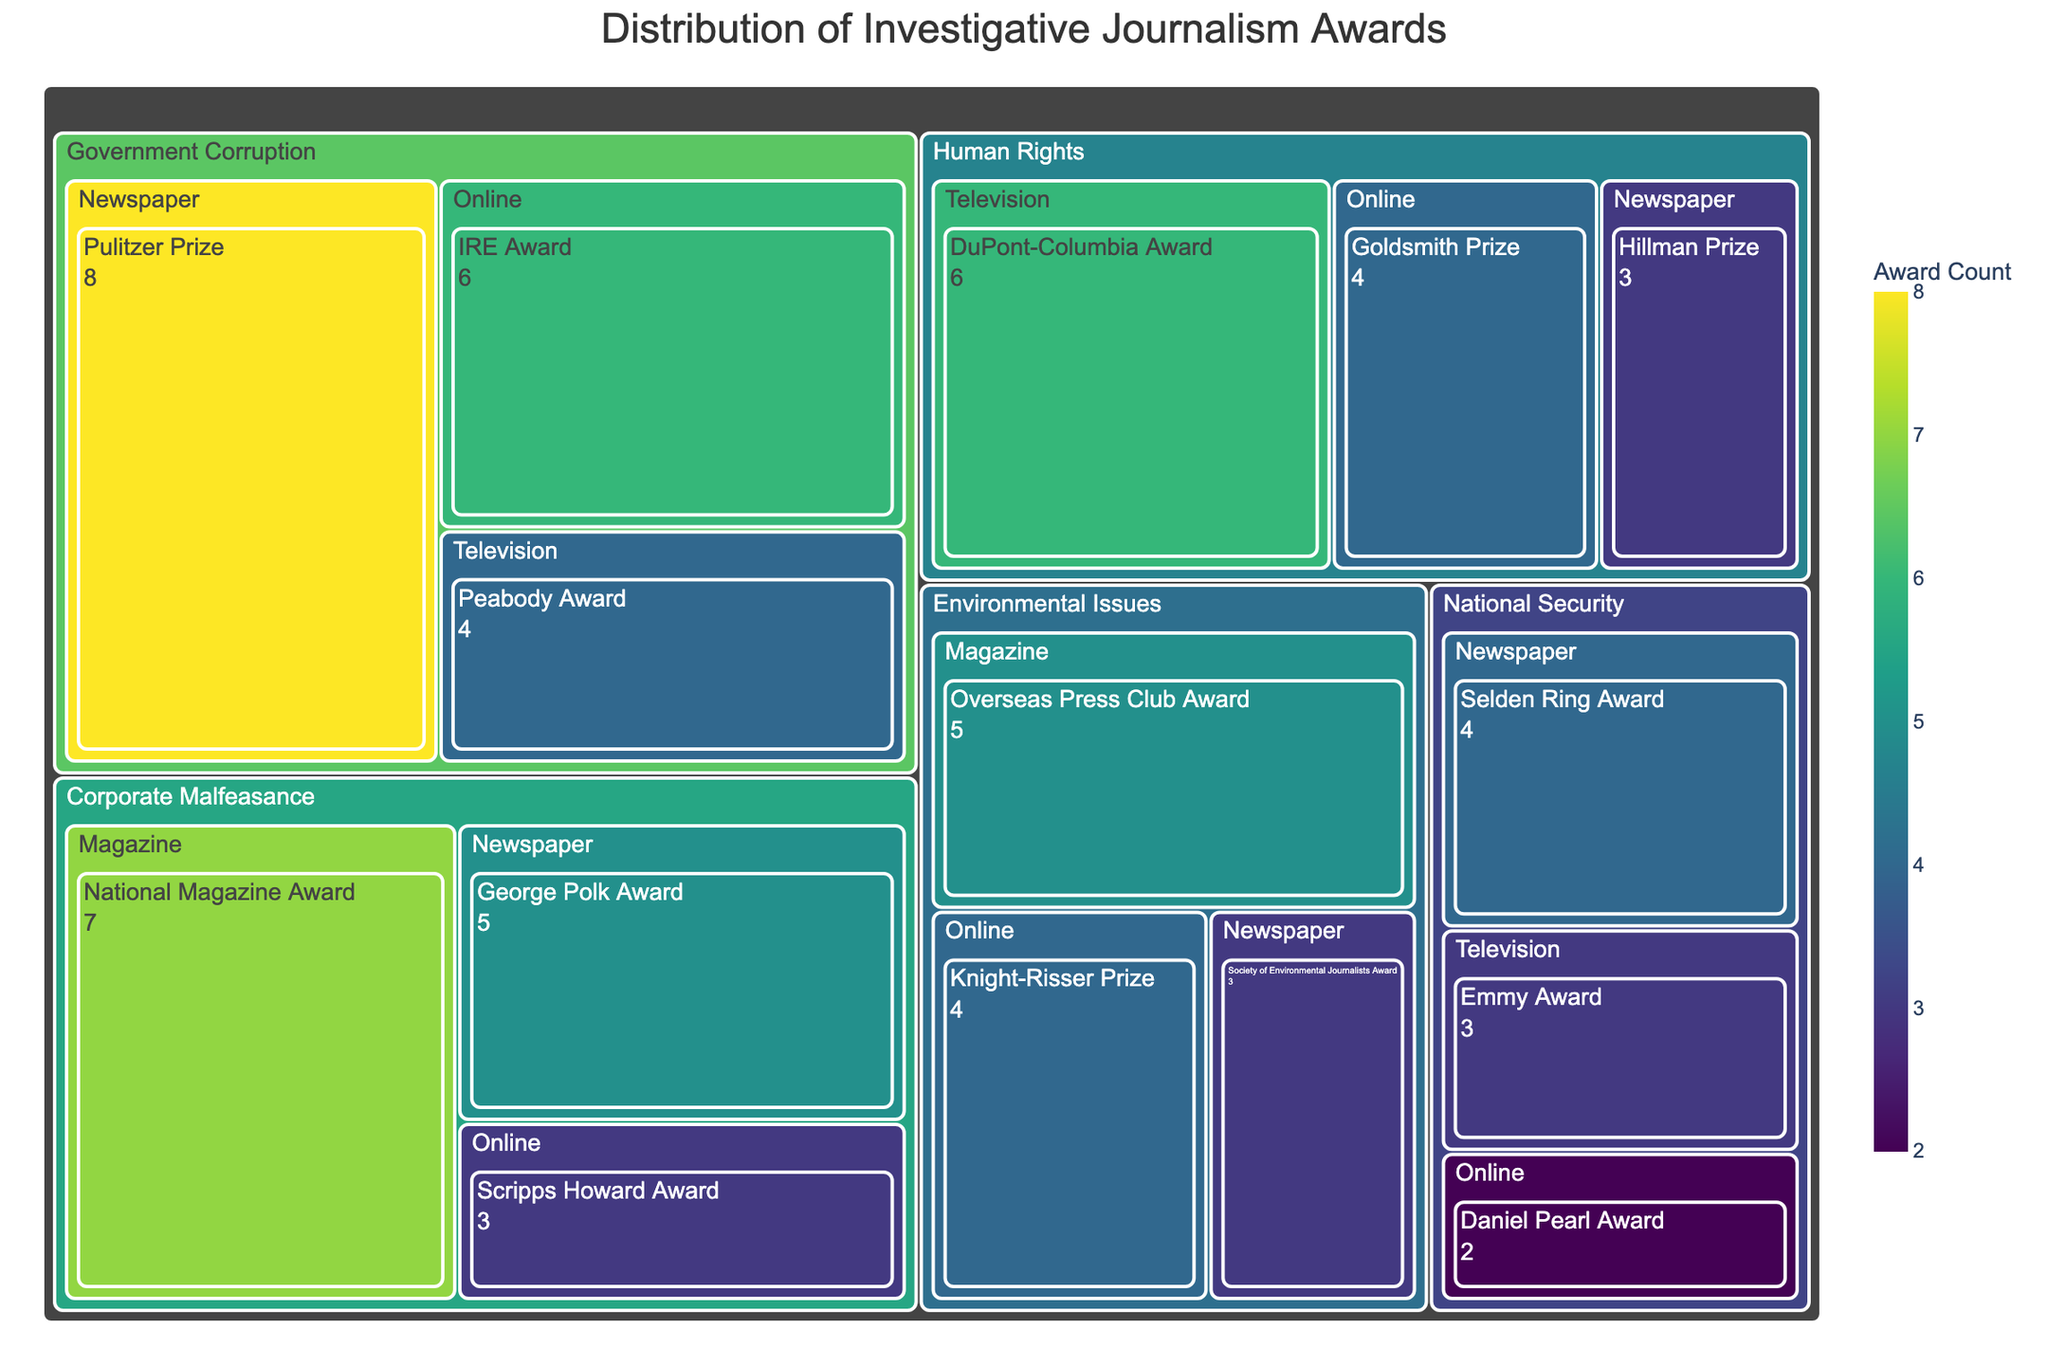How many awards are listed for Government Corruption? Look at the Government Corruption section and sum the values for each publication type: 8 (Newspaper) + 6 (Online) + 4 (Television) = 18
Answer: 18 Which category has the highest total number of awards? Compare the total count of awards across all categories by summing each category's values: Government Corruption = 18, Corporate Malfeasance = 15, Human Rights = 13, Environmental Issues = 12, National Security = 9. Government Corruption has the highest total with 18 awards.
Answer: Government Corruption What is the total number of awards for Online publications across all categories? Add the counts for Online publications: Government Corruption = 6, Corporate Malfeasance = 3, Human Rights = 4, Environmental Issues = 4, National Security = 2. Total = 6 + 3 + 4 + 4 + 2 = 19
Answer: 19 Which award has the highest count for Environmental Issues? Look within the Environmental Issues section and compare the values for the different awards: Overseas Press Club Award (5), Knight-Risser Prize (4), Society of Environmental Journalists Award (3). The Overseas Press Club Award has the highest count with 5.
Answer: Overseas Press Club Award Compare the number of awards given by Television for Human Rights and National Security. Which one is greater? Look at the counts for Television in the sections for Human Rights and National Security: Human Rights = 6, National Security = 3. Human Rights has a greater count.
Answer: Human Rights What's the difference in the total count between Government Corruption and Corporate Malfeasance? The total count for Government Corruption is 18, and for Corporate Malfeasance is 15. The difference is 18 - 15 = 3.
Answer: 3 How many categories have awards given by Online publications? Check each category to see if there are awards given by Online publications: Government Corruption, Corporate Malfeasance, Human Rights, Environmental Issues, National Security. Total = 5 categories.
Answer: 5 What is the sum of awards given by Newspapers for all categories? Add the values for Newspaper awards: Government Corruption = 8, Corporate Malfeasance = 5, Human Rights = 3, Environmental Issues = 3, National Security = 4. Total = 8 + 5 + 3 + 3 + 4 = 23
Answer: 23 Which category has the lowest total number of awards? Compare the total counts across all categories: Government Corruption = 18, Corporate Malfeasance = 15, Human Rights = 13, Environmental Issues = 12, National Security = 9. National Security has the lowest total with 9 awards.
Answer: National Security Which publication type has received awards in all categories? Check each publication type across all categories to see which one appears in each: Newspaper, Online, and Television. Only “Online” appears in Government Corruption, Corporate Malfeasance, Human Rights, Environmental Issues, and National Security.
Answer: Online 